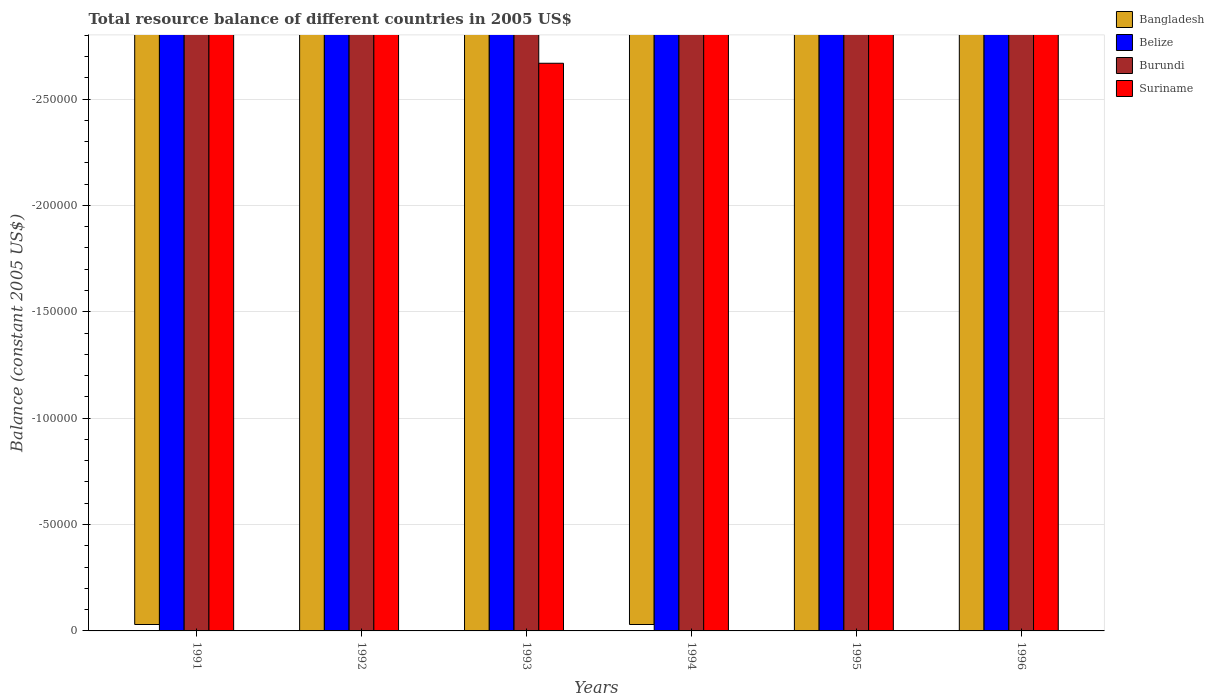Are the number of bars per tick equal to the number of legend labels?
Your response must be concise. No. Are the number of bars on each tick of the X-axis equal?
Provide a short and direct response. Yes. In how many cases, is the number of bars for a given year not equal to the number of legend labels?
Your response must be concise. 6. What is the total resource balance in Burundi in 1994?
Offer a terse response. 0. Across all years, what is the minimum total resource balance in Belize?
Provide a short and direct response. 0. What is the total total resource balance in Belize in the graph?
Offer a terse response. 0. What is the difference between the total resource balance in Bangladesh in 1996 and the total resource balance in Suriname in 1994?
Your response must be concise. 0. What is the average total resource balance in Burundi per year?
Offer a terse response. 0. In how many years, is the total resource balance in Bangladesh greater than the average total resource balance in Bangladesh taken over all years?
Provide a succinct answer. 0. Is it the case that in every year, the sum of the total resource balance in Burundi and total resource balance in Belize is greater than the sum of total resource balance in Suriname and total resource balance in Bangladesh?
Make the answer very short. No. Is it the case that in every year, the sum of the total resource balance in Burundi and total resource balance in Suriname is greater than the total resource balance in Bangladesh?
Your response must be concise. No. How many bars are there?
Your response must be concise. 0. What is the difference between two consecutive major ticks on the Y-axis?
Keep it short and to the point. 5.00e+04. Does the graph contain any zero values?
Provide a short and direct response. Yes. What is the title of the graph?
Provide a succinct answer. Total resource balance of different countries in 2005 US$. What is the label or title of the X-axis?
Your answer should be compact. Years. What is the label or title of the Y-axis?
Keep it short and to the point. Balance (constant 2005 US$). What is the Balance (constant 2005 US$) in Bangladesh in 1991?
Offer a very short reply. 0. What is the Balance (constant 2005 US$) in Belize in 1991?
Provide a short and direct response. 0. What is the Balance (constant 2005 US$) of Burundi in 1991?
Provide a succinct answer. 0. What is the Balance (constant 2005 US$) of Belize in 1992?
Your answer should be very brief. 0. What is the Balance (constant 2005 US$) in Burundi in 1992?
Your answer should be compact. 0. What is the Balance (constant 2005 US$) of Belize in 1994?
Ensure brevity in your answer.  0. What is the Balance (constant 2005 US$) in Burundi in 1994?
Ensure brevity in your answer.  0. What is the Balance (constant 2005 US$) of Suriname in 1994?
Keep it short and to the point. 0. What is the Balance (constant 2005 US$) of Burundi in 1995?
Ensure brevity in your answer.  0. What is the Balance (constant 2005 US$) of Suriname in 1995?
Make the answer very short. 0. What is the Balance (constant 2005 US$) in Burundi in 1996?
Offer a very short reply. 0. What is the Balance (constant 2005 US$) in Suriname in 1996?
Your response must be concise. 0. What is the total Balance (constant 2005 US$) in Bangladesh in the graph?
Your answer should be very brief. 0. What is the total Balance (constant 2005 US$) in Burundi in the graph?
Provide a short and direct response. 0. What is the average Balance (constant 2005 US$) of Bangladesh per year?
Your answer should be compact. 0. 